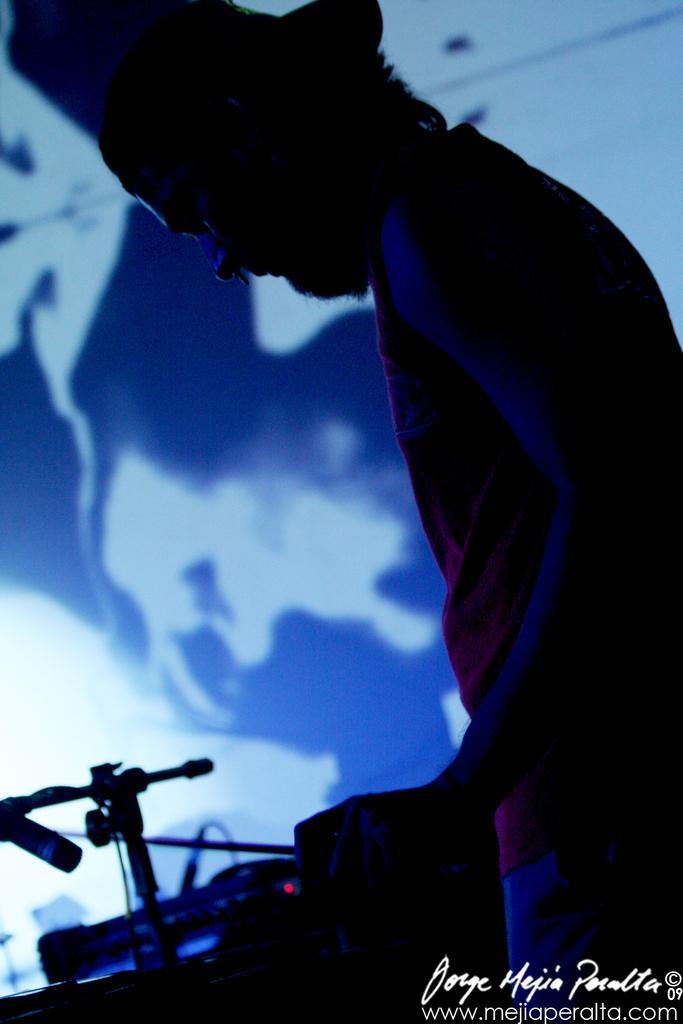Please provide a concise description of this image. In this picture I can see a person and I see few things in front of that person. On the right bottom corner of this picture I can see the watermark. I see that this image is in dark. 